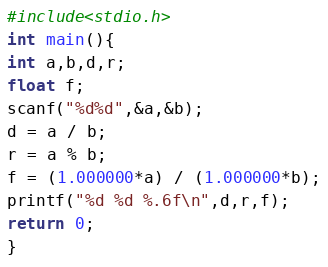Convert code to text. <code><loc_0><loc_0><loc_500><loc_500><_C_>#include<stdio.h>
int main(){
int a,b,d,r;
float f;
scanf("%d%d",&a,&b);
d = a / b;
r = a % b;
f = (1.000000*a) / (1.000000*b);
printf("%d %d %.6f\n",d,r,f);
return 0;
}</code> 